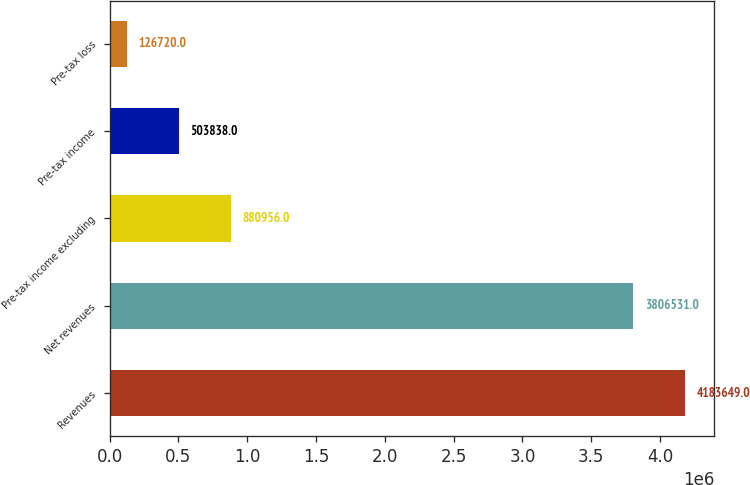Convert chart to OTSL. <chart><loc_0><loc_0><loc_500><loc_500><bar_chart><fcel>Revenues<fcel>Net revenues<fcel>Pre-tax income excluding<fcel>Pre-tax income<fcel>Pre-tax loss<nl><fcel>4.18365e+06<fcel>3.80653e+06<fcel>880956<fcel>503838<fcel>126720<nl></chart> 